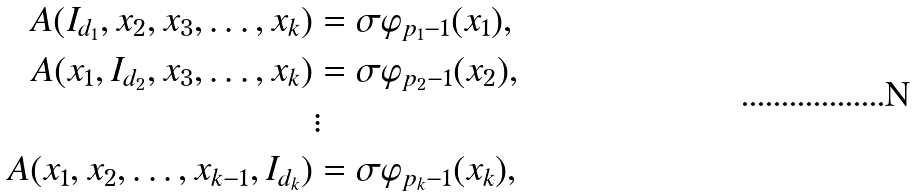Convert formula to latex. <formula><loc_0><loc_0><loc_500><loc_500>A ( I _ { d _ { 1 } } , x _ { 2 } , x _ { 3 } , \dots , x _ { k } ) & = \sigma \varphi _ { p _ { 1 } - 1 } ( x _ { 1 } ) , \\ A ( x _ { 1 } , I _ { d _ { 2 } } , x _ { 3 } , \dots , x _ { k } ) & = \sigma \varphi _ { p _ { 2 } - 1 } ( x _ { 2 } ) , \\ & \vdots \\ A ( x _ { 1 } , x _ { 2 } , \dots , x _ { k - 1 } , I _ { d _ { k } } ) & = \sigma \varphi _ { p _ { k } - 1 } ( x _ { k } ) ,</formula> 